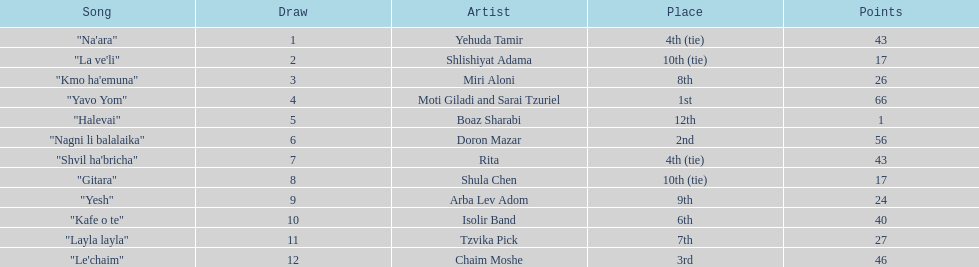What are the number of times an artist earned first place? 1. 